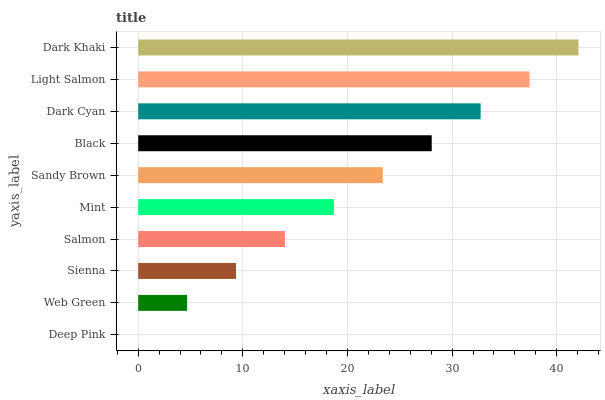Is Deep Pink the minimum?
Answer yes or no. Yes. Is Dark Khaki the maximum?
Answer yes or no. Yes. Is Web Green the minimum?
Answer yes or no. No. Is Web Green the maximum?
Answer yes or no. No. Is Web Green greater than Deep Pink?
Answer yes or no. Yes. Is Deep Pink less than Web Green?
Answer yes or no. Yes. Is Deep Pink greater than Web Green?
Answer yes or no. No. Is Web Green less than Deep Pink?
Answer yes or no. No. Is Sandy Brown the high median?
Answer yes or no. Yes. Is Mint the low median?
Answer yes or no. Yes. Is Black the high median?
Answer yes or no. No. Is Salmon the low median?
Answer yes or no. No. 